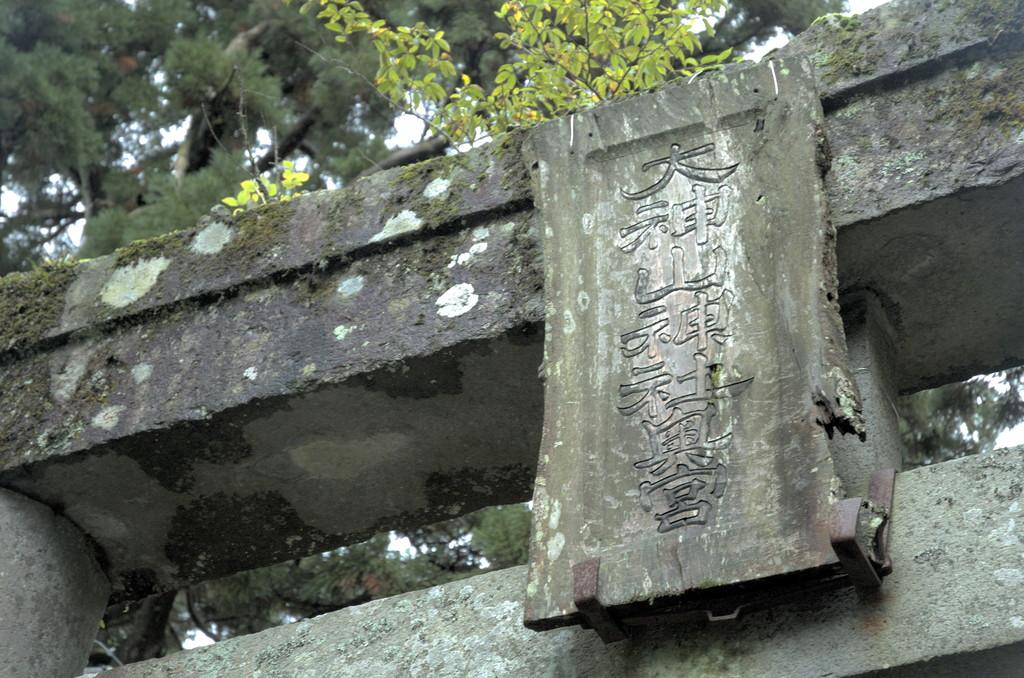What is on the wall in the image? There is a board on the wall in the image. What can be seen on the board? There is something written on the board. What can be seen in the background of the image? There are trees in the background of the image. What type of breakfast is being served on the board in the image? There is no breakfast present in the image; it features a wall with a board on it. Can you tell me how many fowls are visible in the image? There are no fowls present in the image. 